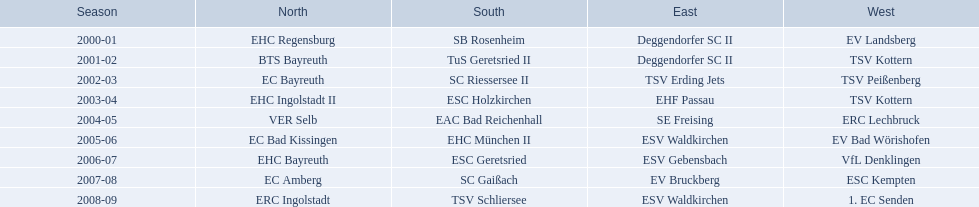Which teams emerged victorious in the north during their specific years? 2000-01, EHC Regensburg, BTS Bayreuth, EC Bayreuth, EHC Ingolstadt II, VER Selb, EC Bad Kissingen, EHC Bayreuth, EC Amberg, ERC Ingolstadt. Which team triumphed solely in 2000-01? EHC Regensburg. 